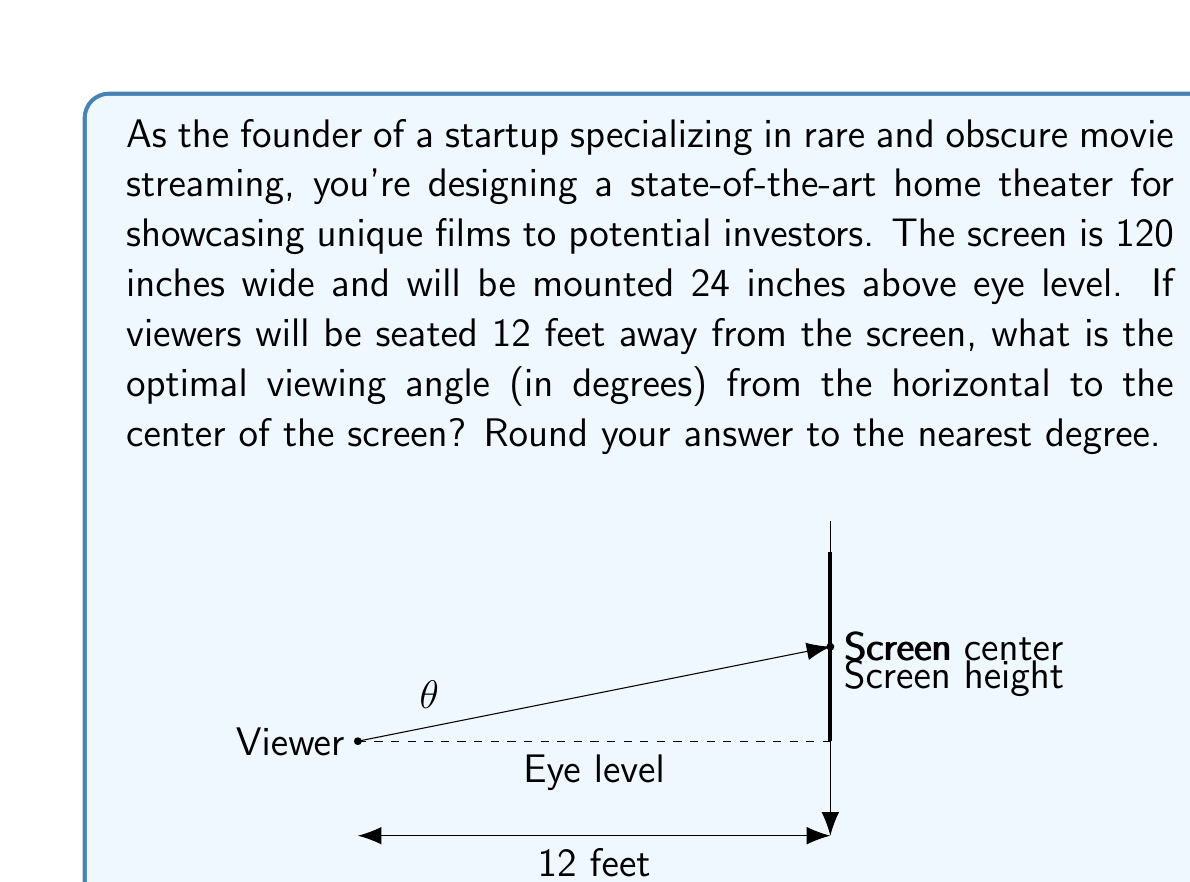Help me with this question. To solve this problem, we'll use trigonometry to find the angle between the horizontal line of sight and the line to the center of the screen.

Let's break it down step by step:

1) First, we need to find the vertical distance from eye level to the center of the screen:
   - The screen is mounted 24 inches above eye level
   - The screen is 120 inches wide, so assuming a 16:9 aspect ratio, its height is (120 * 9/16) = 67.5 inches
   - The center of the screen is half of this height above the mounting point: 67.5/2 = 33.75 inches
   - So the total vertical distance from eye level to screen center is: 24 + 33.75 = 57.75 inches

2) Now we have a right triangle with:
   - Adjacent side (horizontal distance) = 12 feet = 144 inches
   - Opposite side (vertical distance) = 57.75 inches

3) We can use the arctangent function to find the angle:

   $$\theta = \arctan(\frac{\text{opposite}}{\text{adjacent}})$$

   $$\theta = \arctan(\frac{57.75}{144})$$

4) Calculating this:
   $$\theta = \arctan(0.4010417) \approx 21.84^\circ$$

5) Rounding to the nearest degree:
   $$\theta \approx 22^\circ$$

Therefore, the optimal viewing angle from the horizontal to the center of the screen is approximately 22 degrees.
Answer: 22° 